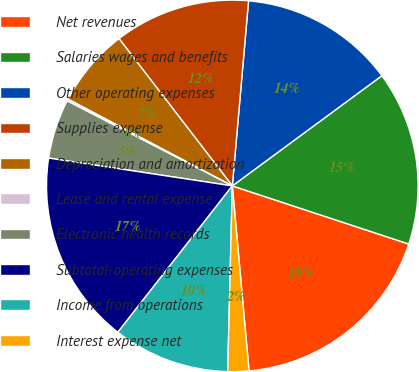Convert chart. <chart><loc_0><loc_0><loc_500><loc_500><pie_chart><fcel>Net revenues<fcel>Salaries wages and benefits<fcel>Other operating expenses<fcel>Supplies expense<fcel>Depreciation and amortization<fcel>Lease and rental expense<fcel>Electronic health records<fcel>Subtotal-operating expenses<fcel>Income from operations<fcel>Interest expense net<nl><fcel>18.5%<fcel>15.17%<fcel>13.5%<fcel>11.83%<fcel>6.83%<fcel>0.17%<fcel>5.17%<fcel>16.83%<fcel>10.17%<fcel>1.83%<nl></chart> 